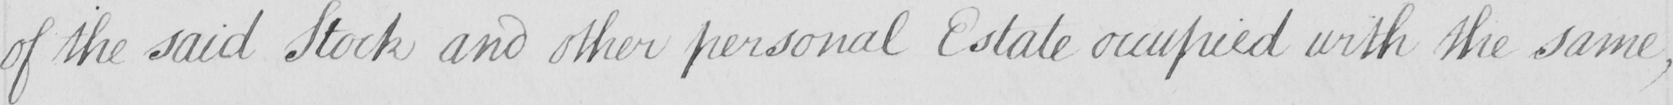Can you read and transcribe this handwriting? of the said Stock and other personal Estate occupied with the same , 